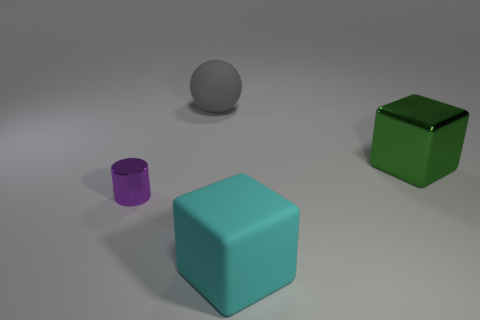Add 3 cyan matte blocks. How many objects exist? 7 Subtract all cylinders. How many objects are left? 3 Add 2 big gray objects. How many big gray objects exist? 3 Subtract 0 gray cylinders. How many objects are left? 4 Subtract all big metallic objects. Subtract all small brown rubber cylinders. How many objects are left? 3 Add 3 big gray balls. How many big gray balls are left? 4 